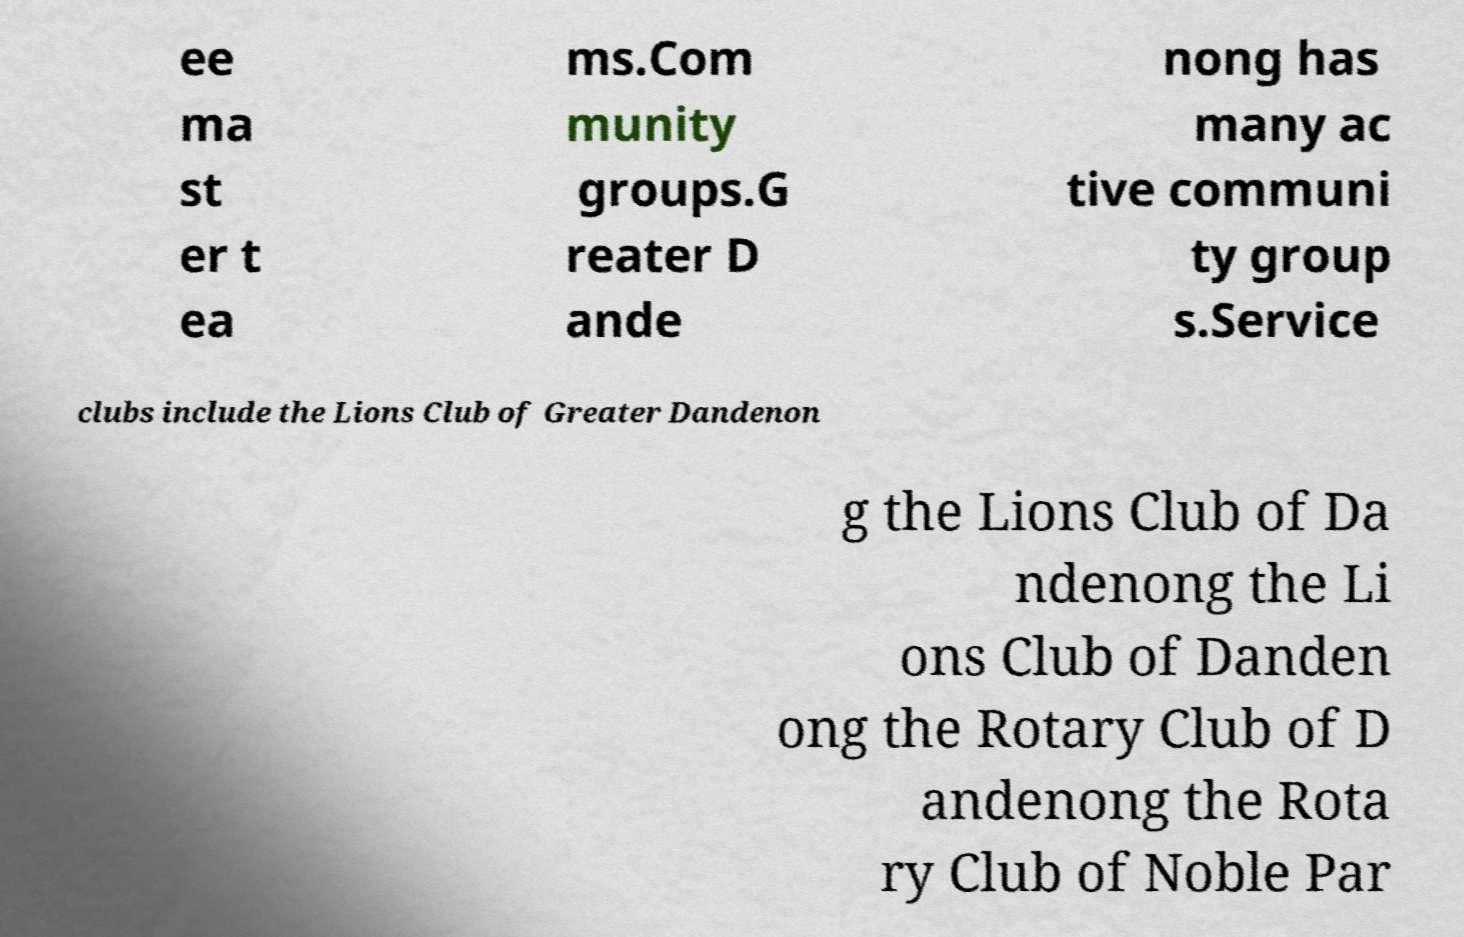What messages or text are displayed in this image? I need them in a readable, typed format. ee ma st er t ea ms.Com munity groups.G reater D ande nong has many ac tive communi ty group s.Service clubs include the Lions Club of Greater Dandenon g the Lions Club of Da ndenong the Li ons Club of Danden ong the Rotary Club of D andenong the Rota ry Club of Noble Par 